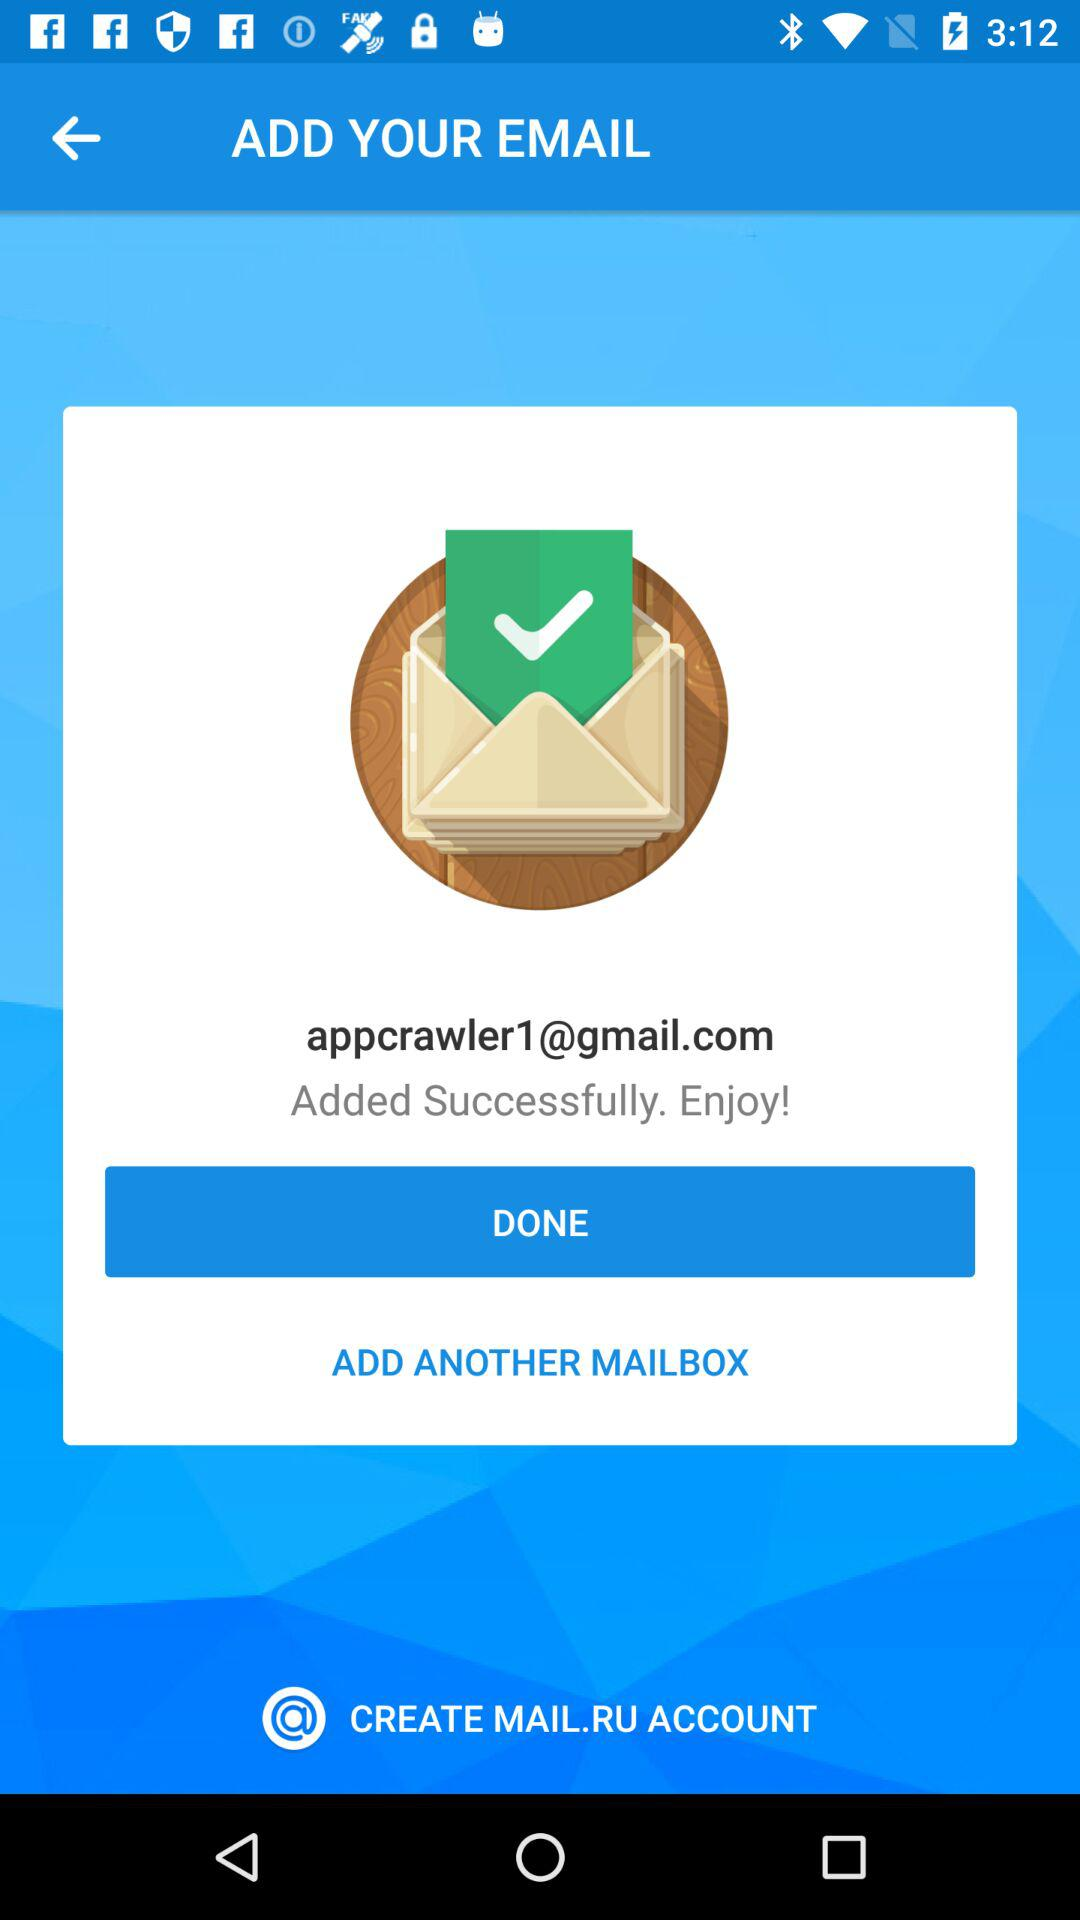What is the email address? The email address is appcrawler1@gmail.com. 